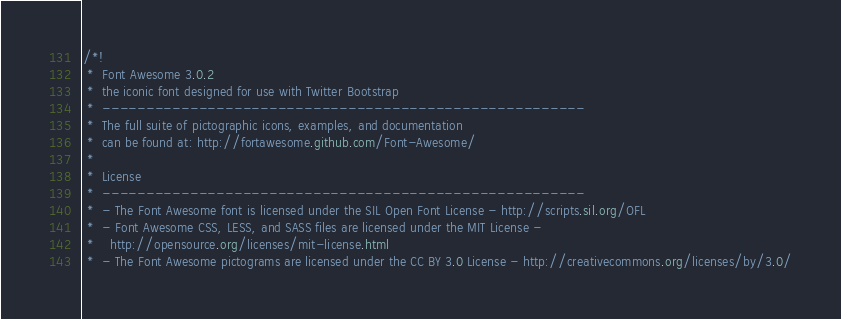Convert code to text. <code><loc_0><loc_0><loc_500><loc_500><_CSS_>/*!
 *  Font Awesome 3.0.2
 *  the iconic font designed for use with Twitter Bootstrap
 *  -------------------------------------------------------
 *  The full suite of pictographic icons, examples, and documentation
 *  can be found at: http://fortawesome.github.com/Font-Awesome/
 *
 *  License
 *  -------------------------------------------------------
 *  - The Font Awesome font is licensed under the SIL Open Font License - http://scripts.sil.org/OFL
 *  - Font Awesome CSS, LESS, and SASS files are licensed under the MIT License -
 *    http://opensource.org/licenses/mit-license.html
 *  - The Font Awesome pictograms are licensed under the CC BY 3.0 License - http://creativecommons.org/licenses/by/3.0/</code> 